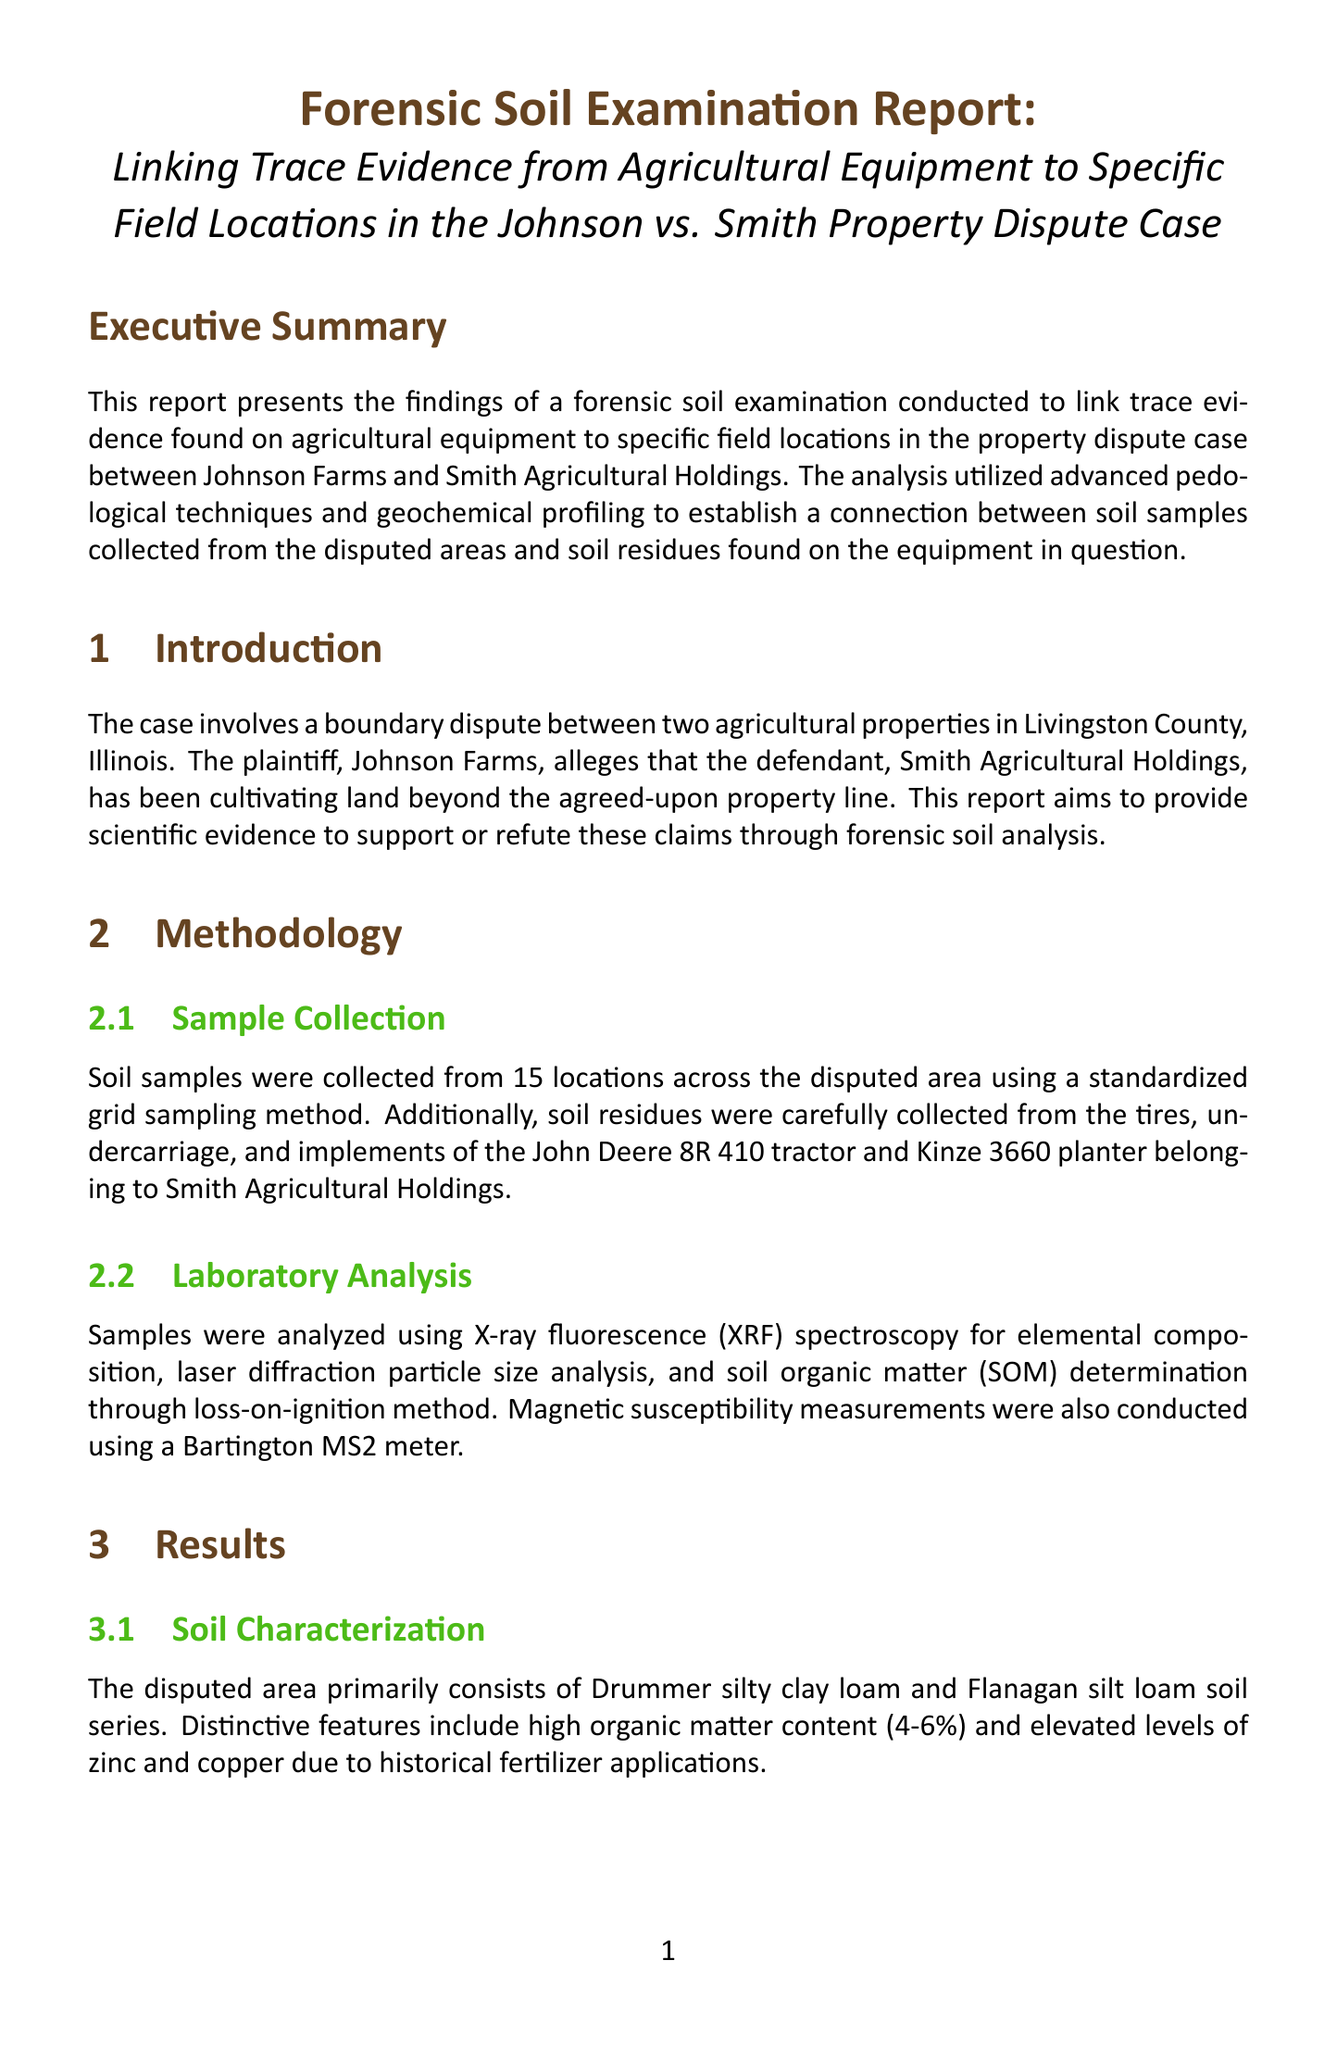What is the title of the report? The title of the report is explicitly stated at the top of the document.
Answer: Forensic Soil Examination Report: Linking Trace Evidence from Agricultural Equipment to Specific Field Locations in the Johnson vs. Smith Property Dispute Case Who conducted the forensic soil examination? The report mentions the expert responsible for the analysis in the expert information section.
Answer: Dr. Emily Thornton What soil series were identified in the disputed area? The report describes the soil series found in the results section.
Answer: Drummer silty clay loam and Flanagan silt loam What method was used for elemental composition analysis? The methodology section specifies the analysis technique used to determine elemental composition.
Answer: X-ray fluorescence (XRF) spectroscopy What correlation coefficient was found in the trace evidence analysis? The results section provides specific details on the statistical analysis of the soil residues.
Answer: r² > 0.95 Which agricultural equipment was examined in this report? The methodology section mentions the specific agricultural equipment being analyzed for trace evidence.
Answer: John Deere 8R 410 tractor and Kinze 3660 planter What major element levels were elevated due to historical fertilizer applications? The results section highlights specific elements that were elevated due to farming practices in the area.
Answer: Zinc and copper What was the conclusion of the forensic soil examination? The conclusion summarizes the findings and implications based on the analyses presented in the report.
Answer: Compelling evidence supports the claim that agricultural equipment has been operating beyond the agreed-upon property line 